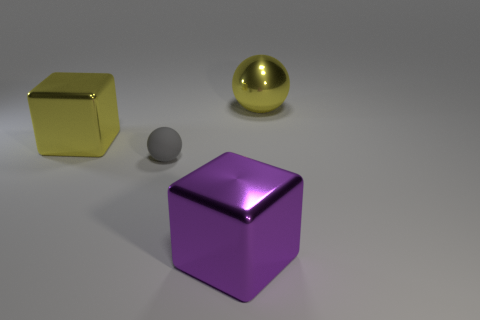Are there fewer purple shiny things in front of the big purple metallic thing than large yellow cubes that are right of the gray rubber object?
Give a very brief answer. No. What number of large green metal things are there?
Offer a terse response. 0. Is there anything else that has the same material as the gray object?
Your answer should be compact. No. What is the material of the big yellow thing that is the same shape as the gray matte thing?
Offer a terse response. Metal. Is the number of rubber things on the right side of the small ball less than the number of big matte cylinders?
Your response must be concise. No. There is a big yellow object to the left of the gray sphere; is its shape the same as the big purple thing?
Offer a very short reply. Yes. Is there any other thing of the same color as the small matte sphere?
Make the answer very short. No. There is a yellow ball that is made of the same material as the large purple block; what size is it?
Your answer should be compact. Large. The big yellow object that is in front of the large thing that is behind the large metal block behind the purple object is made of what material?
Your response must be concise. Metal. Is the number of tiny cubes less than the number of large yellow spheres?
Your response must be concise. Yes. 